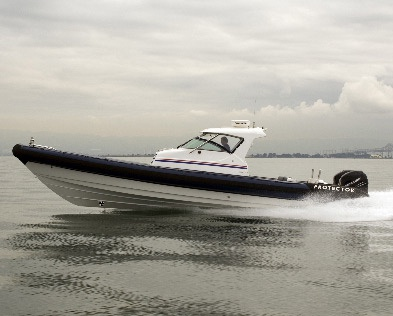Describe the objects in this image and their specific colors. I can see boat in lightgray, black, gray, and darkgray tones and people in lightgray, gray, black, and darkgray tones in this image. 